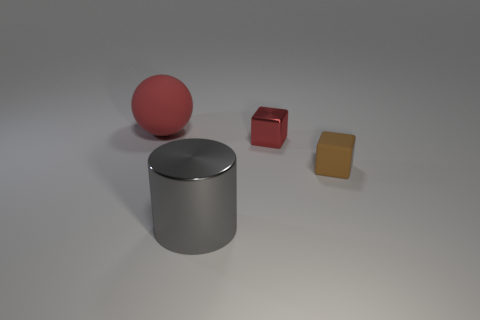Are there more tiny brown cubes that are to the right of the small brown cube than big things that are behind the tiny red metallic cube? Upon examining the image, it appears that there is only one tiny brown cube to the right of the small brown cube, and as for big things behind the tiny red metallic cube, there appears to be only one large silver cylindrical object. Therefore, the count of each is equal, with one item in each category mentioned in the question. 